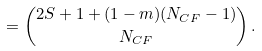<formula> <loc_0><loc_0><loc_500><loc_500>= { 2 S + 1 + ( 1 - m ) ( N _ { C F } - 1 ) \choose N _ { C F } } \, .</formula> 